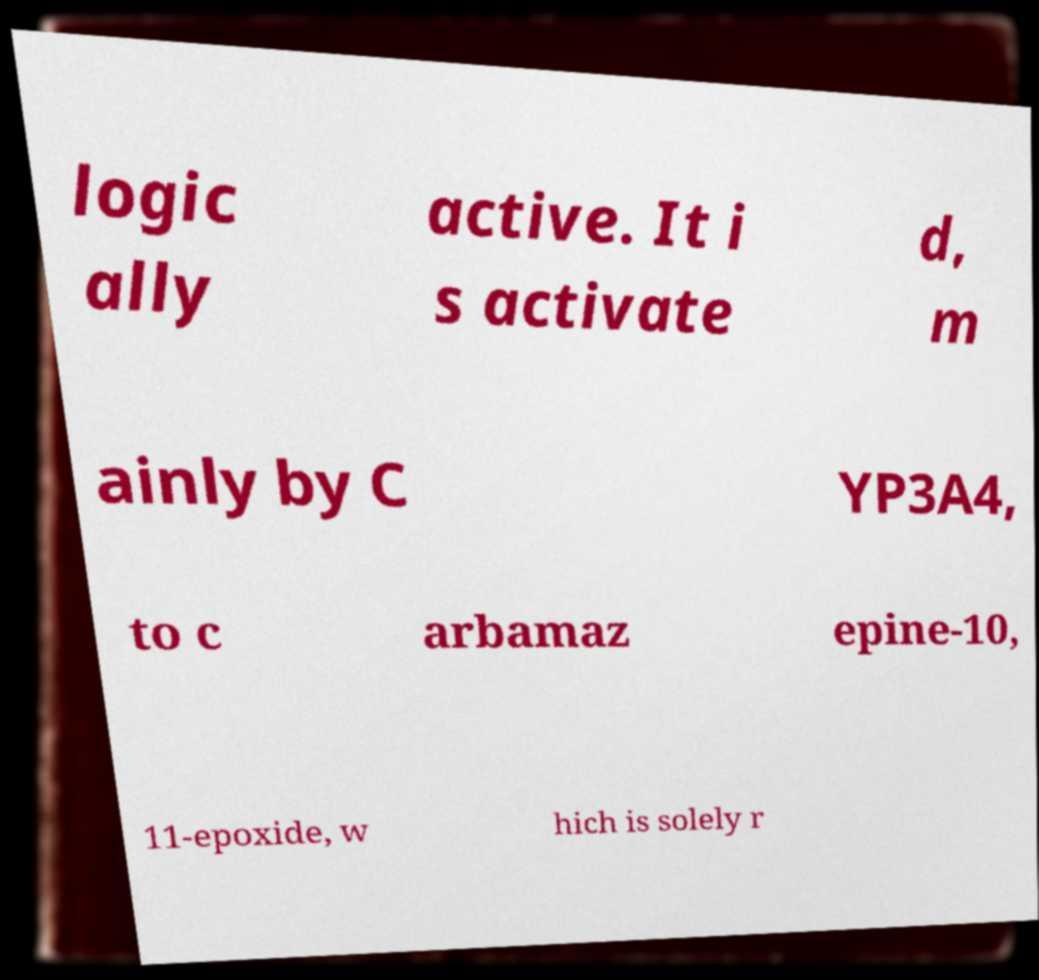Can you read and provide the text displayed in the image?This photo seems to have some interesting text. Can you extract and type it out for me? logic ally active. It i s activate d, m ainly by C YP3A4, to c arbamaz epine-10, 11-epoxide, w hich is solely r 